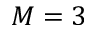Convert formula to latex. <formula><loc_0><loc_0><loc_500><loc_500>M = 3</formula> 